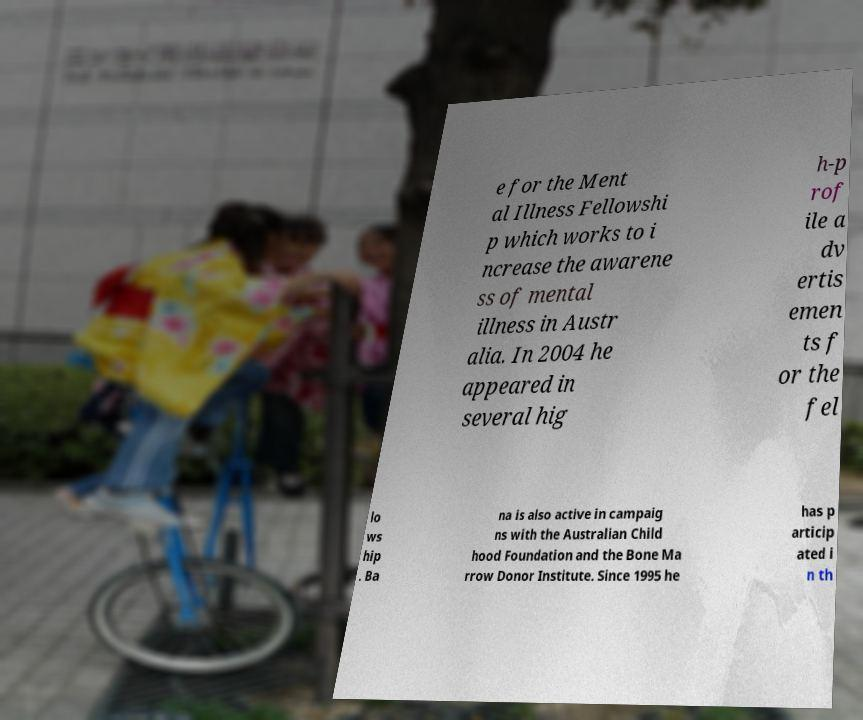Could you assist in decoding the text presented in this image and type it out clearly? e for the Ment al Illness Fellowshi p which works to i ncrease the awarene ss of mental illness in Austr alia. In 2004 he appeared in several hig h-p rof ile a dv ertis emen ts f or the fel lo ws hip . Ba na is also active in campaig ns with the Australian Child hood Foundation and the Bone Ma rrow Donor Institute. Since 1995 he has p articip ated i n th 